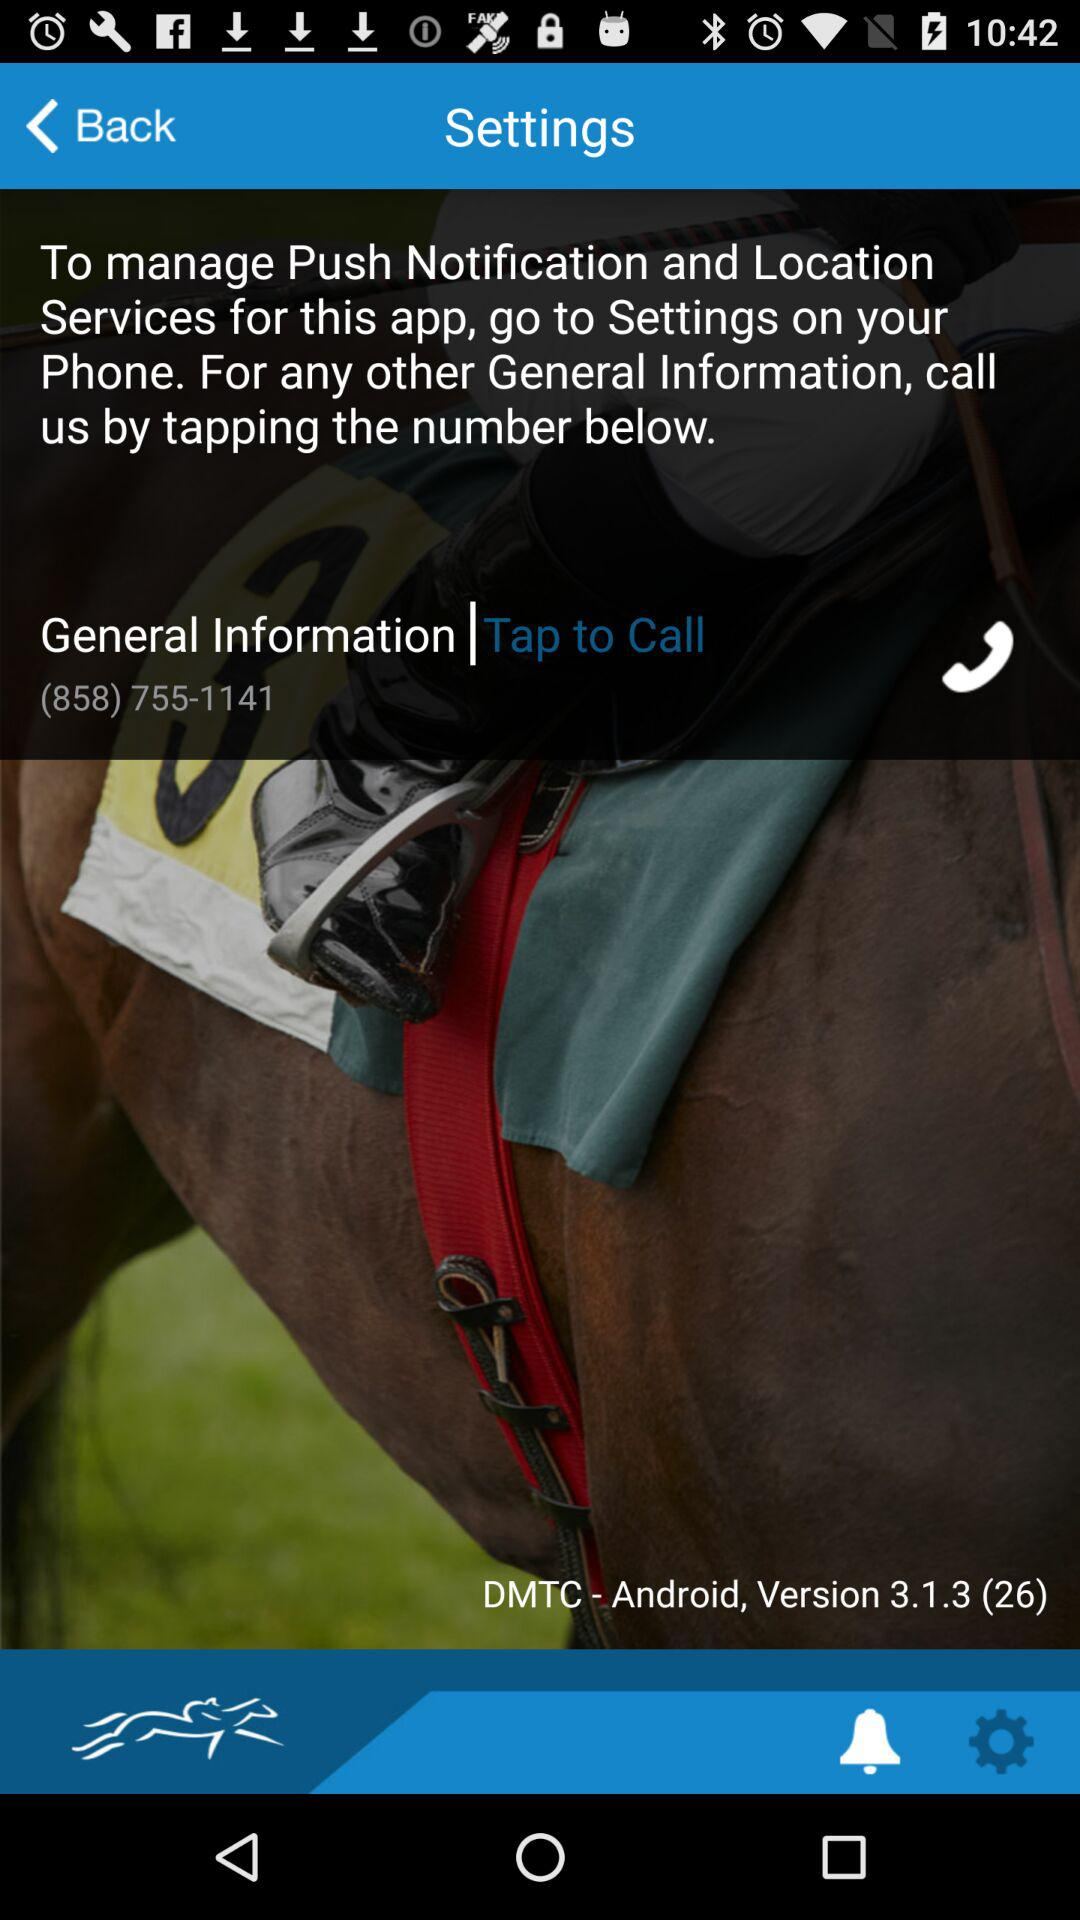What is the given number for calling? The given number for calling is (858) 755-1141. 